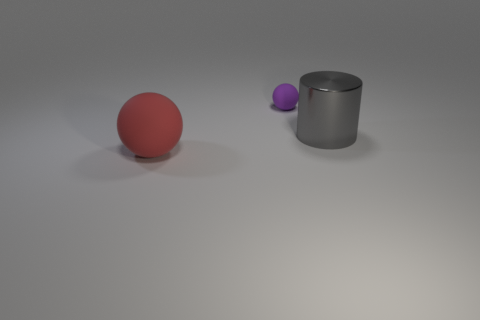Are there any indications of motion or stillness in this image? The image depicts stillness. There are no motion blurs or other indications that the objects are in motion. Everything is stationary, contributing to the calm and settled atmosphere of the scene. 